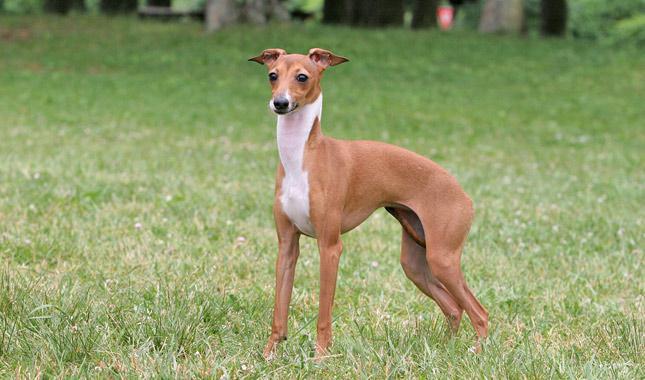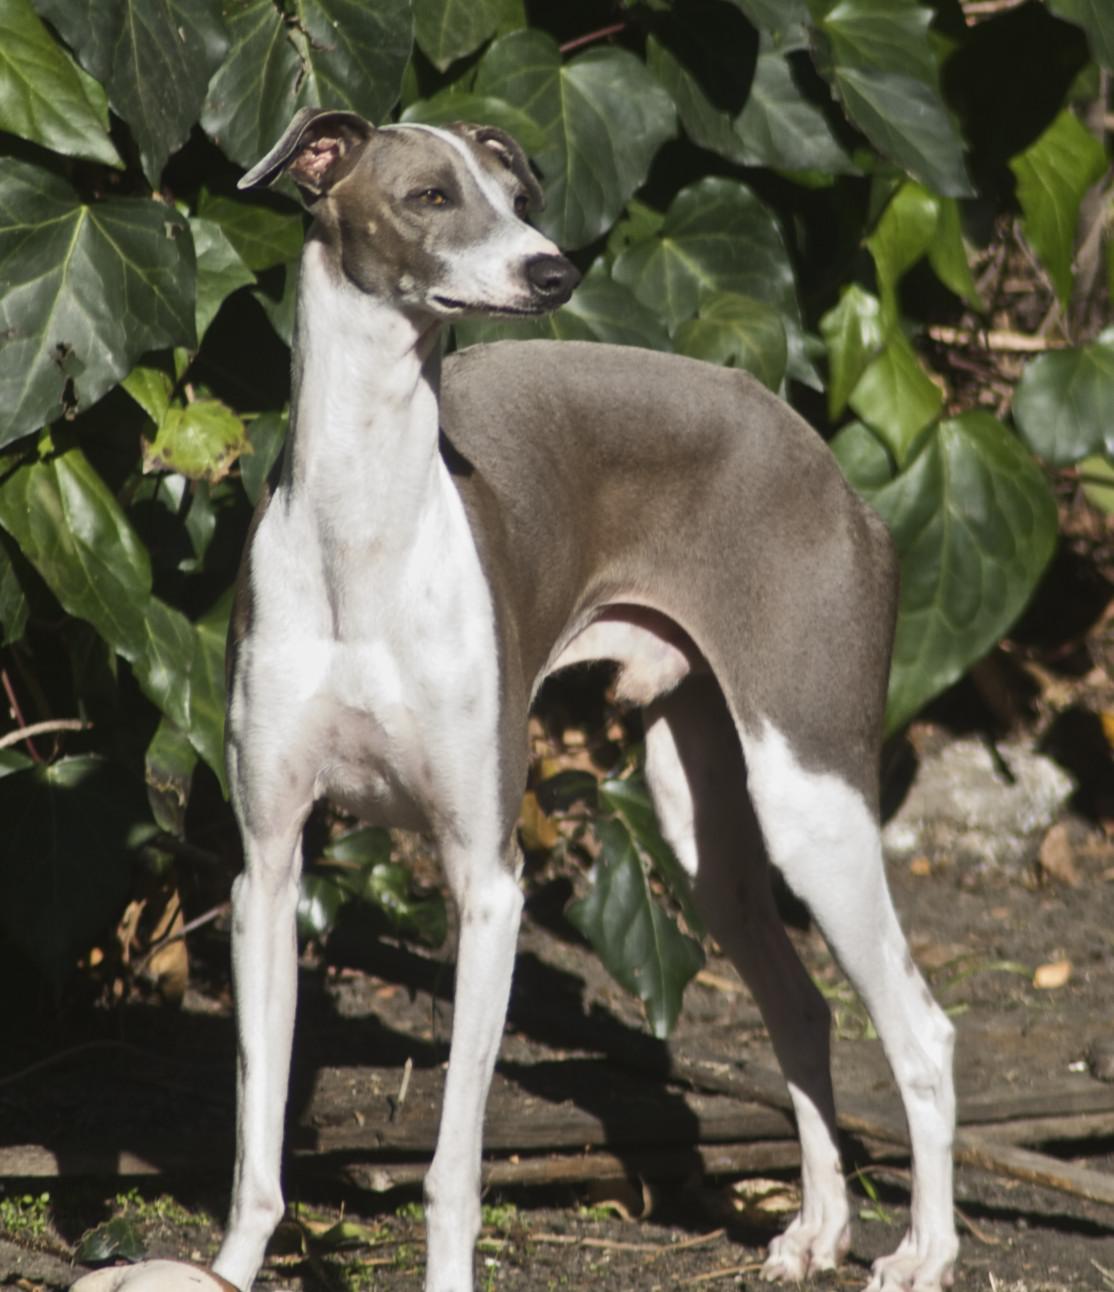The first image is the image on the left, the second image is the image on the right. Evaluate the accuracy of this statement regarding the images: "An image shows one hound posed human-like, with upright head, facing the camera.". Is it true? Answer yes or no. No. The first image is the image on the left, the second image is the image on the right. Assess this claim about the two images: "One of the dogs is standing on all fours in the grass.". Correct or not? Answer yes or no. Yes. 